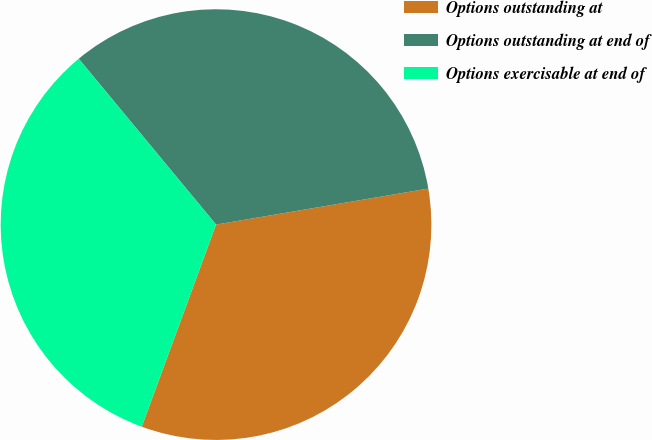Convert chart to OTSL. <chart><loc_0><loc_0><loc_500><loc_500><pie_chart><fcel>Options outstanding at<fcel>Options outstanding at end of<fcel>Options exercisable at end of<nl><fcel>33.28%<fcel>33.33%<fcel>33.39%<nl></chart> 